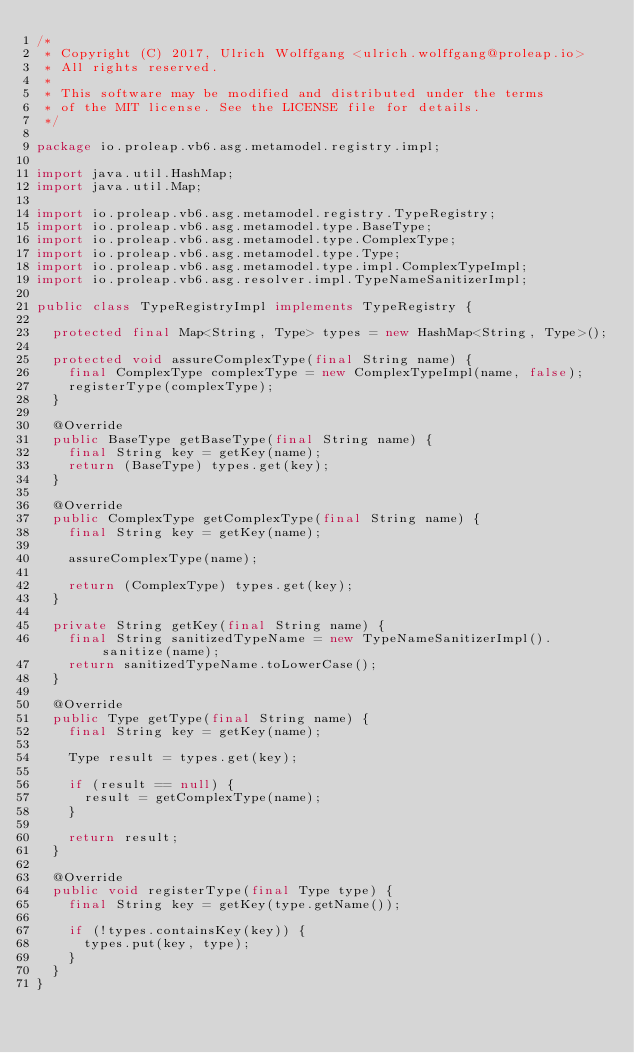<code> <loc_0><loc_0><loc_500><loc_500><_Java_>/*
 * Copyright (C) 2017, Ulrich Wolffgang <ulrich.wolffgang@proleap.io>
 * All rights reserved.
 *
 * This software may be modified and distributed under the terms
 * of the MIT license. See the LICENSE file for details.
 */

package io.proleap.vb6.asg.metamodel.registry.impl;

import java.util.HashMap;
import java.util.Map;

import io.proleap.vb6.asg.metamodel.registry.TypeRegistry;
import io.proleap.vb6.asg.metamodel.type.BaseType;
import io.proleap.vb6.asg.metamodel.type.ComplexType;
import io.proleap.vb6.asg.metamodel.type.Type;
import io.proleap.vb6.asg.metamodel.type.impl.ComplexTypeImpl;
import io.proleap.vb6.asg.resolver.impl.TypeNameSanitizerImpl;

public class TypeRegistryImpl implements TypeRegistry {

	protected final Map<String, Type> types = new HashMap<String, Type>();

	protected void assureComplexType(final String name) {
		final ComplexType complexType = new ComplexTypeImpl(name, false);
		registerType(complexType);
	}

	@Override
	public BaseType getBaseType(final String name) {
		final String key = getKey(name);
		return (BaseType) types.get(key);
	}

	@Override
	public ComplexType getComplexType(final String name) {
		final String key = getKey(name);

		assureComplexType(name);

		return (ComplexType) types.get(key);
	}

	private String getKey(final String name) {
		final String sanitizedTypeName = new TypeNameSanitizerImpl().sanitize(name);
		return sanitizedTypeName.toLowerCase();
	}

	@Override
	public Type getType(final String name) {
		final String key = getKey(name);

		Type result = types.get(key);

		if (result == null) {
			result = getComplexType(name);
		}

		return result;
	}

	@Override
	public void registerType(final Type type) {
		final String key = getKey(type.getName());

		if (!types.containsKey(key)) {
			types.put(key, type);
		}
	}
}
</code> 